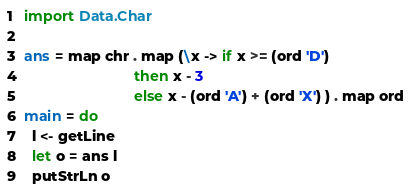<code> <loc_0><loc_0><loc_500><loc_500><_Haskell_>import Data.Char

ans = map chr . map (\x -> if x >= (ord 'D')
                           then x - 3
                           else x - (ord 'A') + (ord 'X') ) . map ord
main = do
  l <- getLine
  let o = ans l
  putStrLn o</code> 